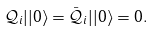<formula> <loc_0><loc_0><loc_500><loc_500>\mathcal { Q } _ { i } | | 0 \rangle = \bar { \mathcal { Q } } _ { i } | | 0 \rangle = 0 .</formula> 